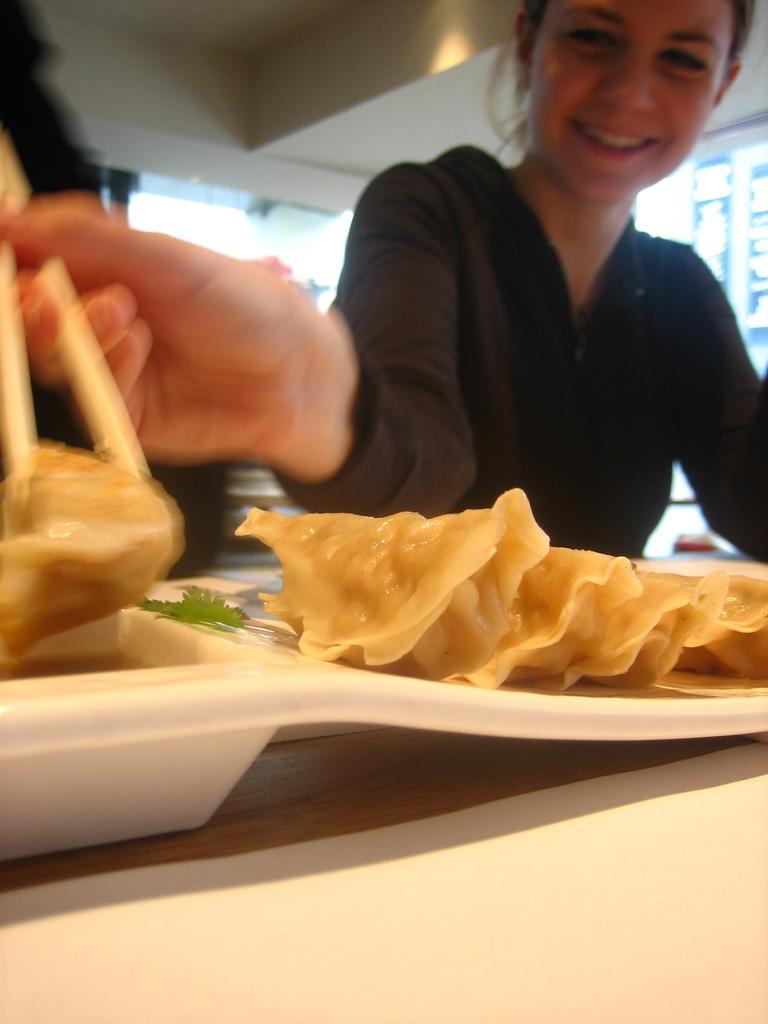Can you describe this image briefly? In the image there is a girl black hoodie holding momos with chopsticks on a table. 